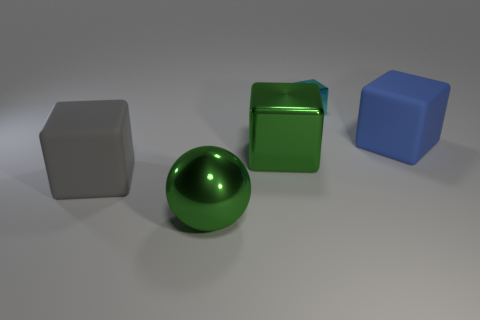What material is the large gray block left of the large green metal cube?
Give a very brief answer. Rubber. What is the size of the metal block that is left of the metallic block that is behind the big blue cube?
Offer a terse response. Large. What number of purple metallic cylinders are the same size as the gray matte cube?
Your answer should be compact. 0. Is the color of the large shiny thing behind the large shiny sphere the same as the object that is in front of the big gray thing?
Your answer should be very brief. Yes. There is a metallic ball; are there any big things behind it?
Your response must be concise. Yes. What color is the cube that is in front of the tiny metal cube and on the right side of the green cube?
Provide a succinct answer. Blue. Are there any large cubes of the same color as the big metallic sphere?
Provide a short and direct response. Yes. Do the cyan object that is right of the sphere and the large thing that is behind the green block have the same material?
Offer a terse response. No. There is a green shiny object that is on the right side of the large ball; what is its size?
Your answer should be compact. Large. What is the size of the blue block?
Offer a very short reply. Large. 